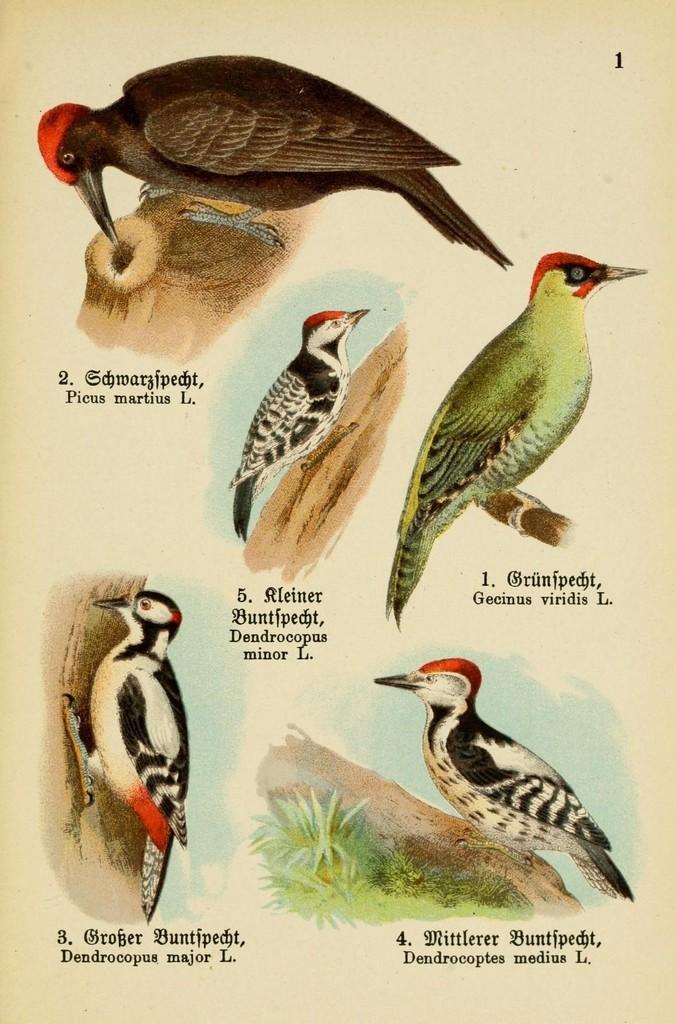How would you summarize this image in a sentence or two? In this image we can see a poster on which there are some different types and colors of birds which are on the branches of trees. 